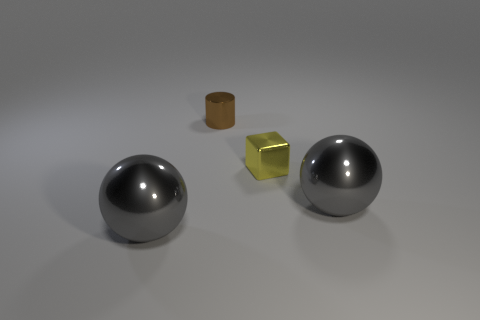Add 3 tiny cubes. How many objects exist? 7 Subtract all cylinders. How many objects are left? 3 Add 2 small shiny blocks. How many small shiny blocks exist? 3 Subtract 0 cyan cubes. How many objects are left? 4 Subtract all tiny purple cylinders. Subtract all balls. How many objects are left? 2 Add 1 big gray metallic things. How many big gray metallic things are left? 3 